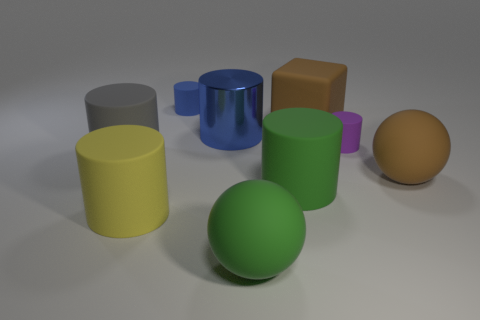Does the metal thing have the same color as the big matte cube?
Your response must be concise. No. Is there anything else that has the same material as the tiny purple object?
Keep it short and to the point. Yes. How many objects are yellow objects or large cylinders left of the big blue metallic cylinder?
Make the answer very short. 2. There is a ball that is on the left side of the purple rubber cylinder; does it have the same size as the big cube?
Offer a very short reply. Yes. What number of other things are there of the same shape as the big yellow thing?
Offer a very short reply. 5. How many gray things are either small rubber objects or matte spheres?
Your answer should be compact. 0. There is a rubber object that is on the left side of the yellow rubber thing; does it have the same color as the cube?
Make the answer very short. No. The blue thing that is the same material as the block is what shape?
Offer a very short reply. Cylinder. What is the color of the big thing that is to the left of the small blue rubber cylinder and to the right of the gray matte thing?
Keep it short and to the point. Yellow. How big is the brown thing in front of the tiny matte object that is on the right side of the brown block?
Ensure brevity in your answer.  Large. 